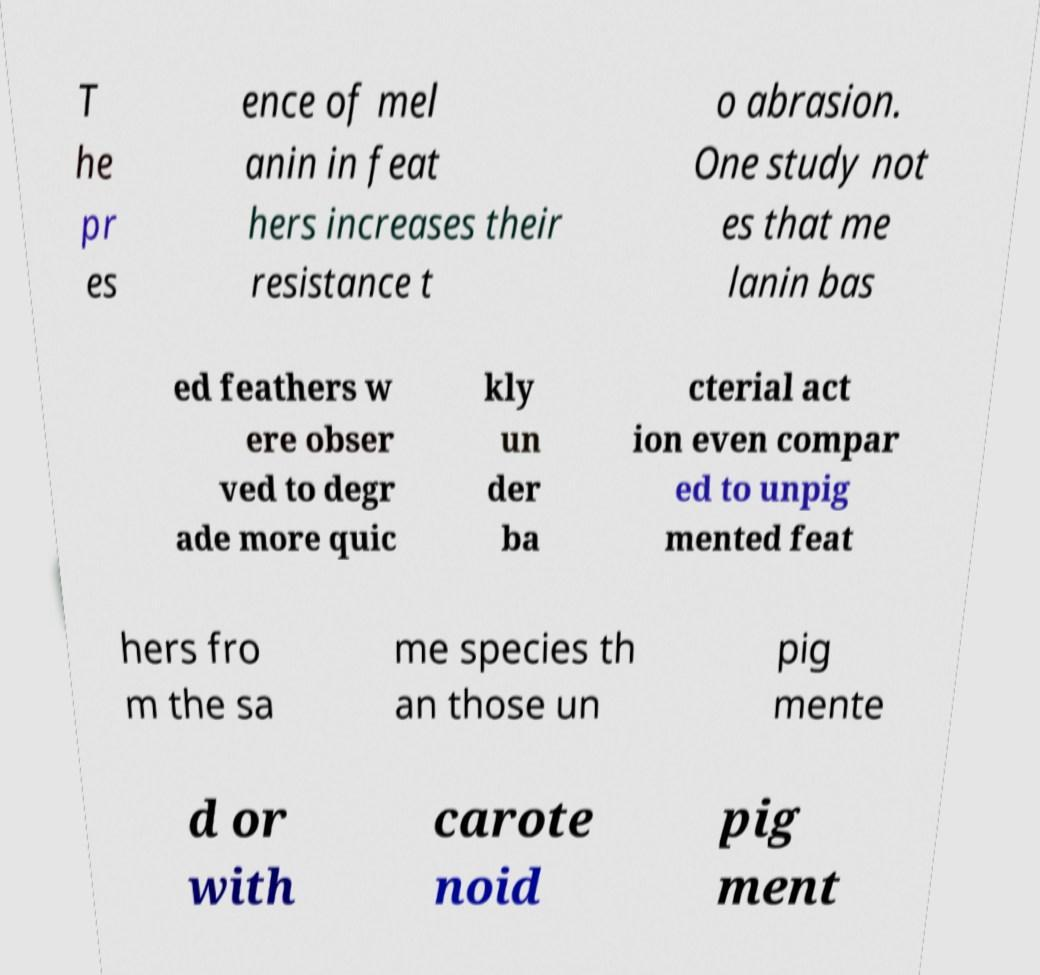What messages or text are displayed in this image? I need them in a readable, typed format. T he pr es ence of mel anin in feat hers increases their resistance t o abrasion. One study not es that me lanin bas ed feathers w ere obser ved to degr ade more quic kly un der ba cterial act ion even compar ed to unpig mented feat hers fro m the sa me species th an those un pig mente d or with carote noid pig ment 